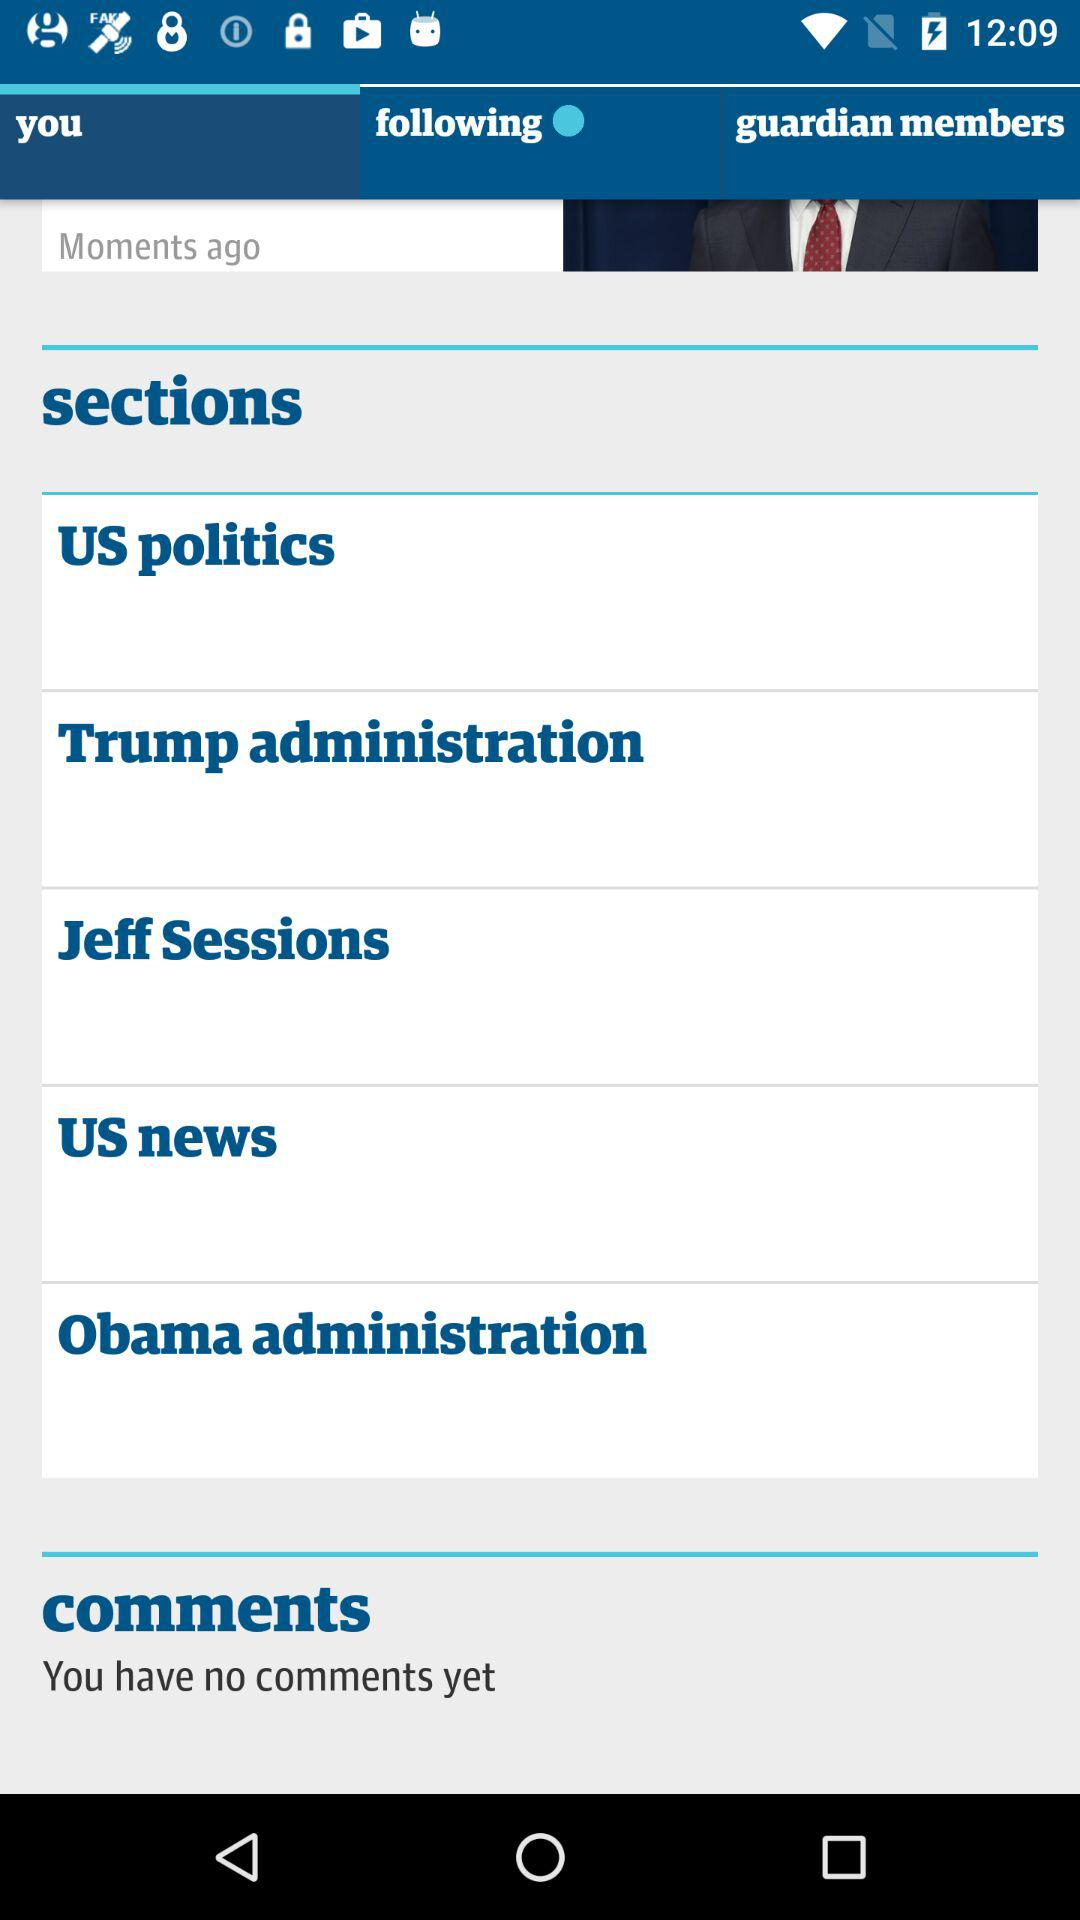What are the available topics? The topics "US politics", "Trump administration", "Jeff Sessions", "US news" and "Obama administration" are available. 